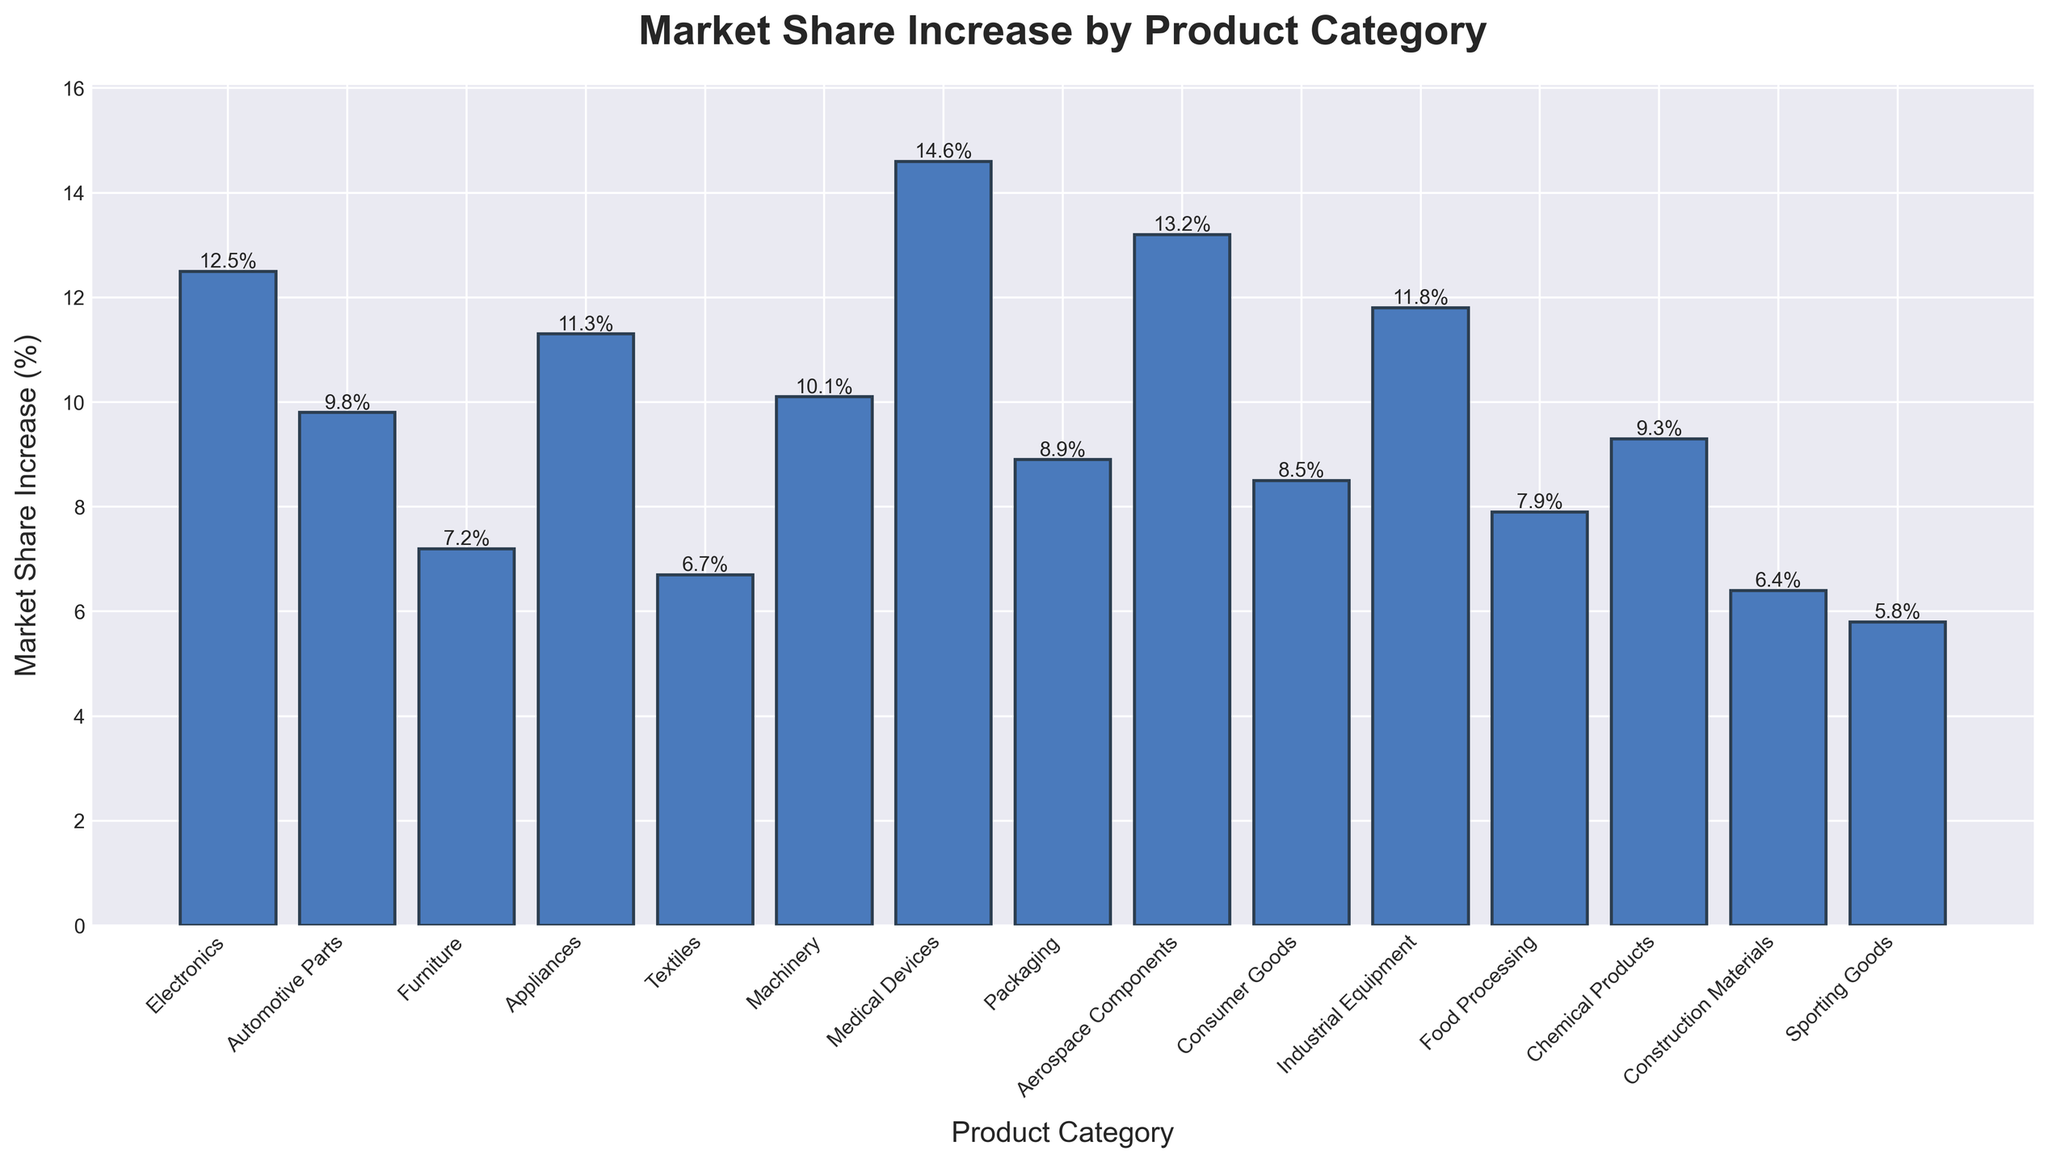What's the product category with the highest market share increase? By observing the heights of the bars, the tallest bar represents the highest market share increase. This bar corresponds to "Medical Devices", with a market share increase of 14.6%.
Answer: Medical Devices Which product category has a lower market share increase, Furniture or Appliances? Comparing the heights of the bars for "Furniture" and "Appliances", "Furniture" has a market share increase of 7.2%, while "Appliances" has 11.3%. Therefore, "Furniture" has a lower market share increase.
Answer: Furniture What's the total market share increase for Textile, Construction Materials, and Sporting Goods combined? The market share increases are given as: Textiles (6.7%), Construction Materials (6.4%), and Sporting Goods (5.8%). Adding them together: 6.7 + 6.4 + 5.8 = 18.9.
Answer: 18.9% How much greater is the market share increase in Industrial Equipment compared to Food Processing? The market share increases are: Industrial Equipment (11.8%) and Food Processing (7.9%). The difference is 11.8% - 7.9% = 3.9%.
Answer: 3.9% Identify the product categories with a market share increase of more than 10%. The categories with a market share increase of more than 10% are: Electronics (12.5%), Appliances (11.3%), Medical Devices (14.6%), Aerospace Components (13.2%), and Industrial Equipment (11.8%).
Answer: Electronics, Appliances, Medical Devices, Aerospace Components, Industrial Equipment What is the average market share increase across all product categories? Summing up all the market share increases: 12.5 + 9.8 + 7.2 + 11.3 + 6.7 + 10.1 + 14.6 + 8.9 + 13.2 + 8.5 + 11.8 + 7.9 + 9.3 + 6.4 + 5.8 = 143.0. There are 15 categories, so the average increase is 143.0 / 15 = 9.53%.
Answer: 9.53% Which product category has the smallest market share increase, and what is its value? The shortest bar in the chart represents the smallest market share increase. This bar corresponds to "Sporting Goods" with a value of 5.8%.
Answer: Sporting Goods, 5.8% What is the increase in market share for Packaging, and how does it compare to Consumer Goods? The market share increases are: Packaging (8.9%) and Consumer Goods (8.5%). Therefore, the increase for Packaging is 0.4% greater than that of Consumer Goods.
Answer: Packaging is 0.4% greater 